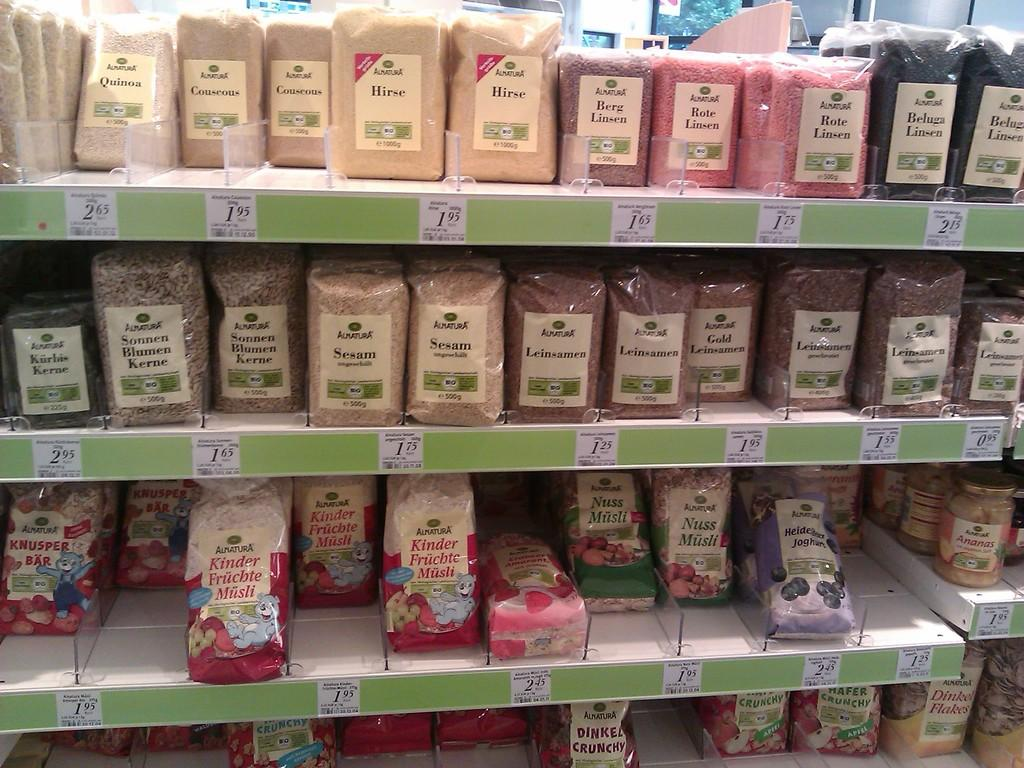What types of food items are visible in the image? There are spices and pulses in the image. How are the spices and pulses stored in the image? The spices and pulses are stored in covers and containers in the image. Where are the covers and containers placed in the image? The covers and containers are placed on shelves in the image. What else can be seen on the shelves besides the spices and pulses? Papers with text and numbers are pasted on the shelves in the image. Can you hear the band playing music in the image? There is no band or music present in the image; it only shows spices, pulses, covers, containers, shelves, and papers with text and numbers. 